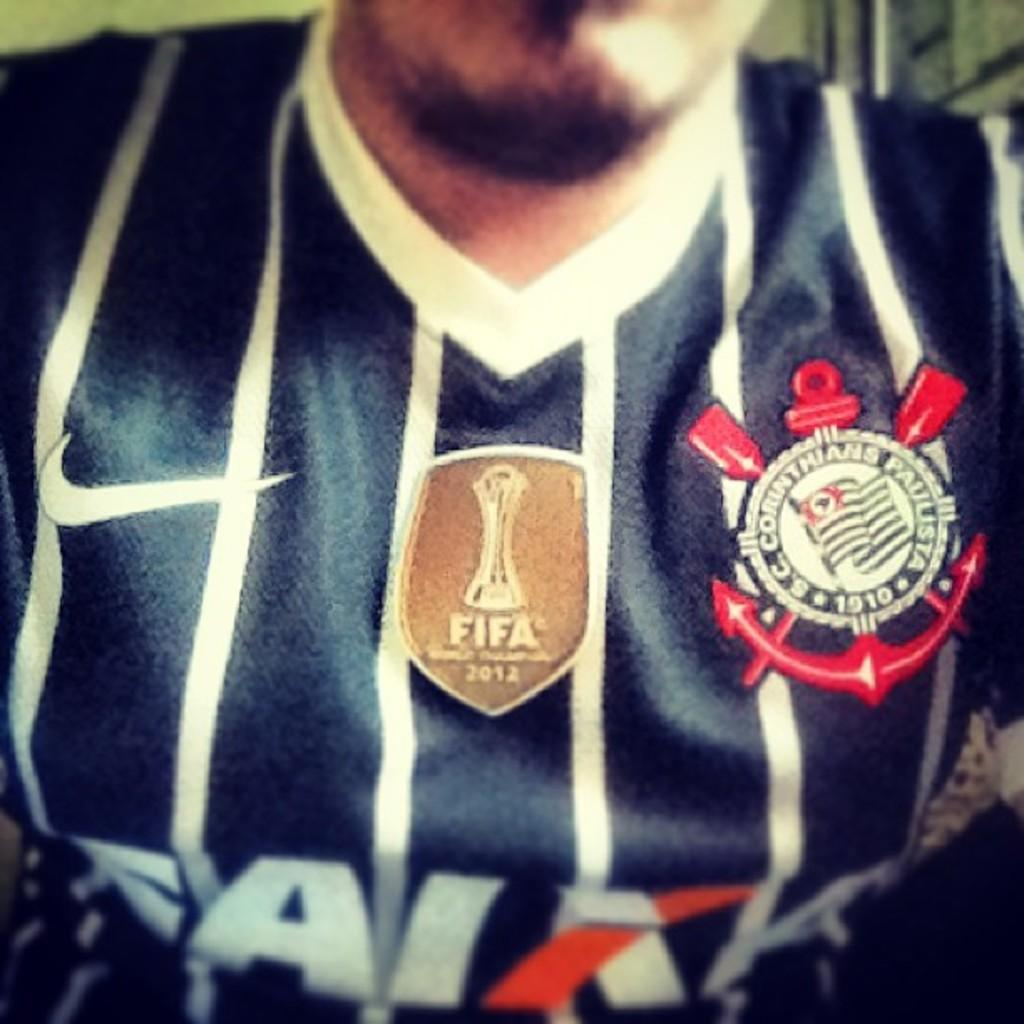Provide a one-sentence caption for the provided image. A closeup of a man wearing a blue FIFA 2012 soccer jersey. 